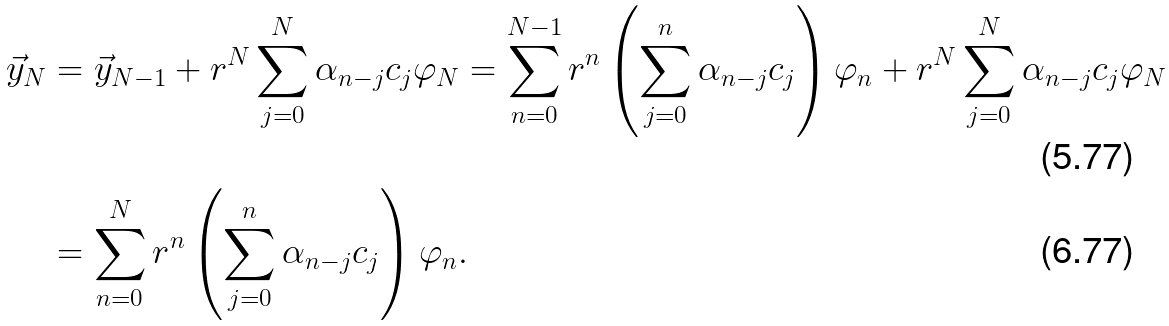<formula> <loc_0><loc_0><loc_500><loc_500>\vec { y } _ { N } & = \vec { y } _ { N - 1 } + r ^ { N } \sum _ { j = 0 } ^ { N } \alpha _ { n - j } c _ { j } \varphi _ { N } = \sum _ { n = 0 } ^ { N - 1 } r ^ { n } \left ( \sum _ { j = 0 } ^ { n } \alpha _ { n - j } c _ { j } \right ) \varphi _ { n } + r ^ { N } \sum _ { j = 0 } ^ { N } \alpha _ { n - j } c _ { j } \varphi _ { N } \\ & = \sum _ { n = 0 } ^ { N } r ^ { n } \left ( \sum _ { j = 0 } ^ { n } \alpha _ { n - j } c _ { j } \right ) \varphi _ { n } .</formula> 